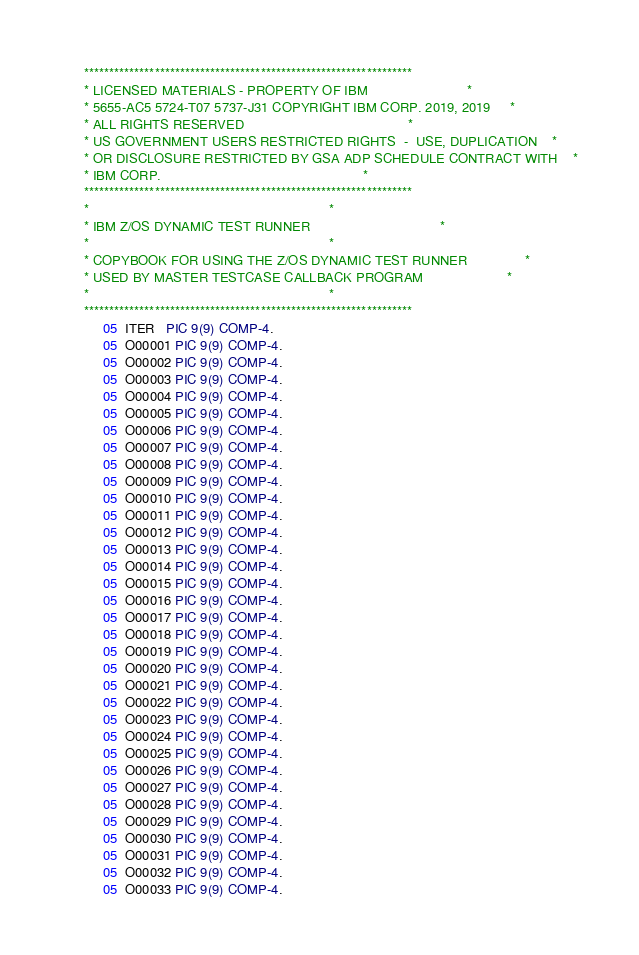<code> <loc_0><loc_0><loc_500><loc_500><_COBOL_>      *****************************************************************
      * LICENSED MATERIALS - PROPERTY OF IBM                          *
      * 5655-AC5 5724-T07 5737-J31 COPYRIGHT IBM CORP. 2019, 2019     *
      * ALL RIGHTS RESERVED                                           *
      * US GOVERNMENT USERS RESTRICTED RIGHTS  -  USE, DUPLICATION    *
      * OR DISCLOSURE RESTRICTED BY GSA ADP SCHEDULE CONTRACT WITH    *
      * IBM CORP.                                                     *
      *****************************************************************
      *                                                               *
      * IBM Z/OS DYNAMIC TEST RUNNER                                  *
      *                                                               *
      * COPYBOOK FOR USING THE Z/OS DYNAMIC TEST RUNNER               *
      * USED BY MASTER TESTCASE CALLBACK PROGRAM                      *
      *                                                               *
      *****************************************************************
           05  ITER   PIC 9(9) COMP-4.
           05  O00001 PIC 9(9) COMP-4.
           05  O00002 PIC 9(9) COMP-4.
           05  O00003 PIC 9(9) COMP-4.
           05  O00004 PIC 9(9) COMP-4.
           05  O00005 PIC 9(9) COMP-4.
           05  O00006 PIC 9(9) COMP-4.
           05  O00007 PIC 9(9) COMP-4.
           05  O00008 PIC 9(9) COMP-4.
           05  O00009 PIC 9(9) COMP-4.
           05  O00010 PIC 9(9) COMP-4.
           05  O00011 PIC 9(9) COMP-4.
           05  O00012 PIC 9(9) COMP-4.
           05  O00013 PIC 9(9) COMP-4.
           05  O00014 PIC 9(9) COMP-4.
           05  O00015 PIC 9(9) COMP-4.
           05  O00016 PIC 9(9) COMP-4.
           05  O00017 PIC 9(9) COMP-4.
           05  O00018 PIC 9(9) COMP-4.
           05  O00019 PIC 9(9) COMP-4.
           05  O00020 PIC 9(9) COMP-4.
           05  O00021 PIC 9(9) COMP-4.
           05  O00022 PIC 9(9) COMP-4.
           05  O00023 PIC 9(9) COMP-4.
           05  O00024 PIC 9(9) COMP-4.
           05  O00025 PIC 9(9) COMP-4.
           05  O00026 PIC 9(9) COMP-4.
           05  O00027 PIC 9(9) COMP-4.
           05  O00028 PIC 9(9) COMP-4.
           05  O00029 PIC 9(9) COMP-4.
           05  O00030 PIC 9(9) COMP-4.
           05  O00031 PIC 9(9) COMP-4.
           05  O00032 PIC 9(9) COMP-4.
           05  O00033 PIC 9(9) COMP-4.</code> 